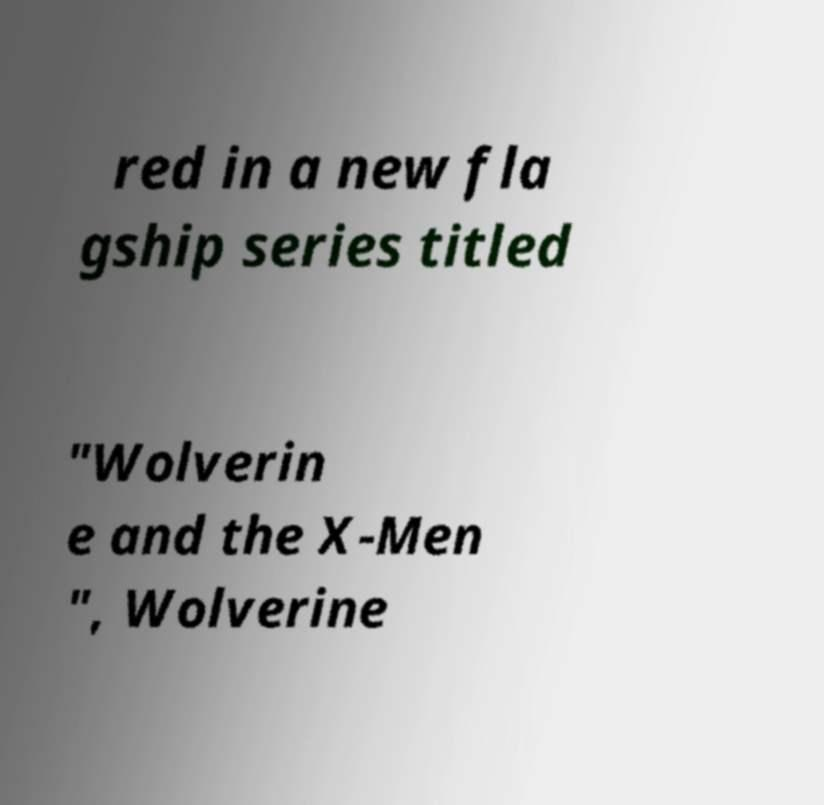Please read and relay the text visible in this image. What does it say? red in a new fla gship series titled "Wolverin e and the X-Men ", Wolverine 